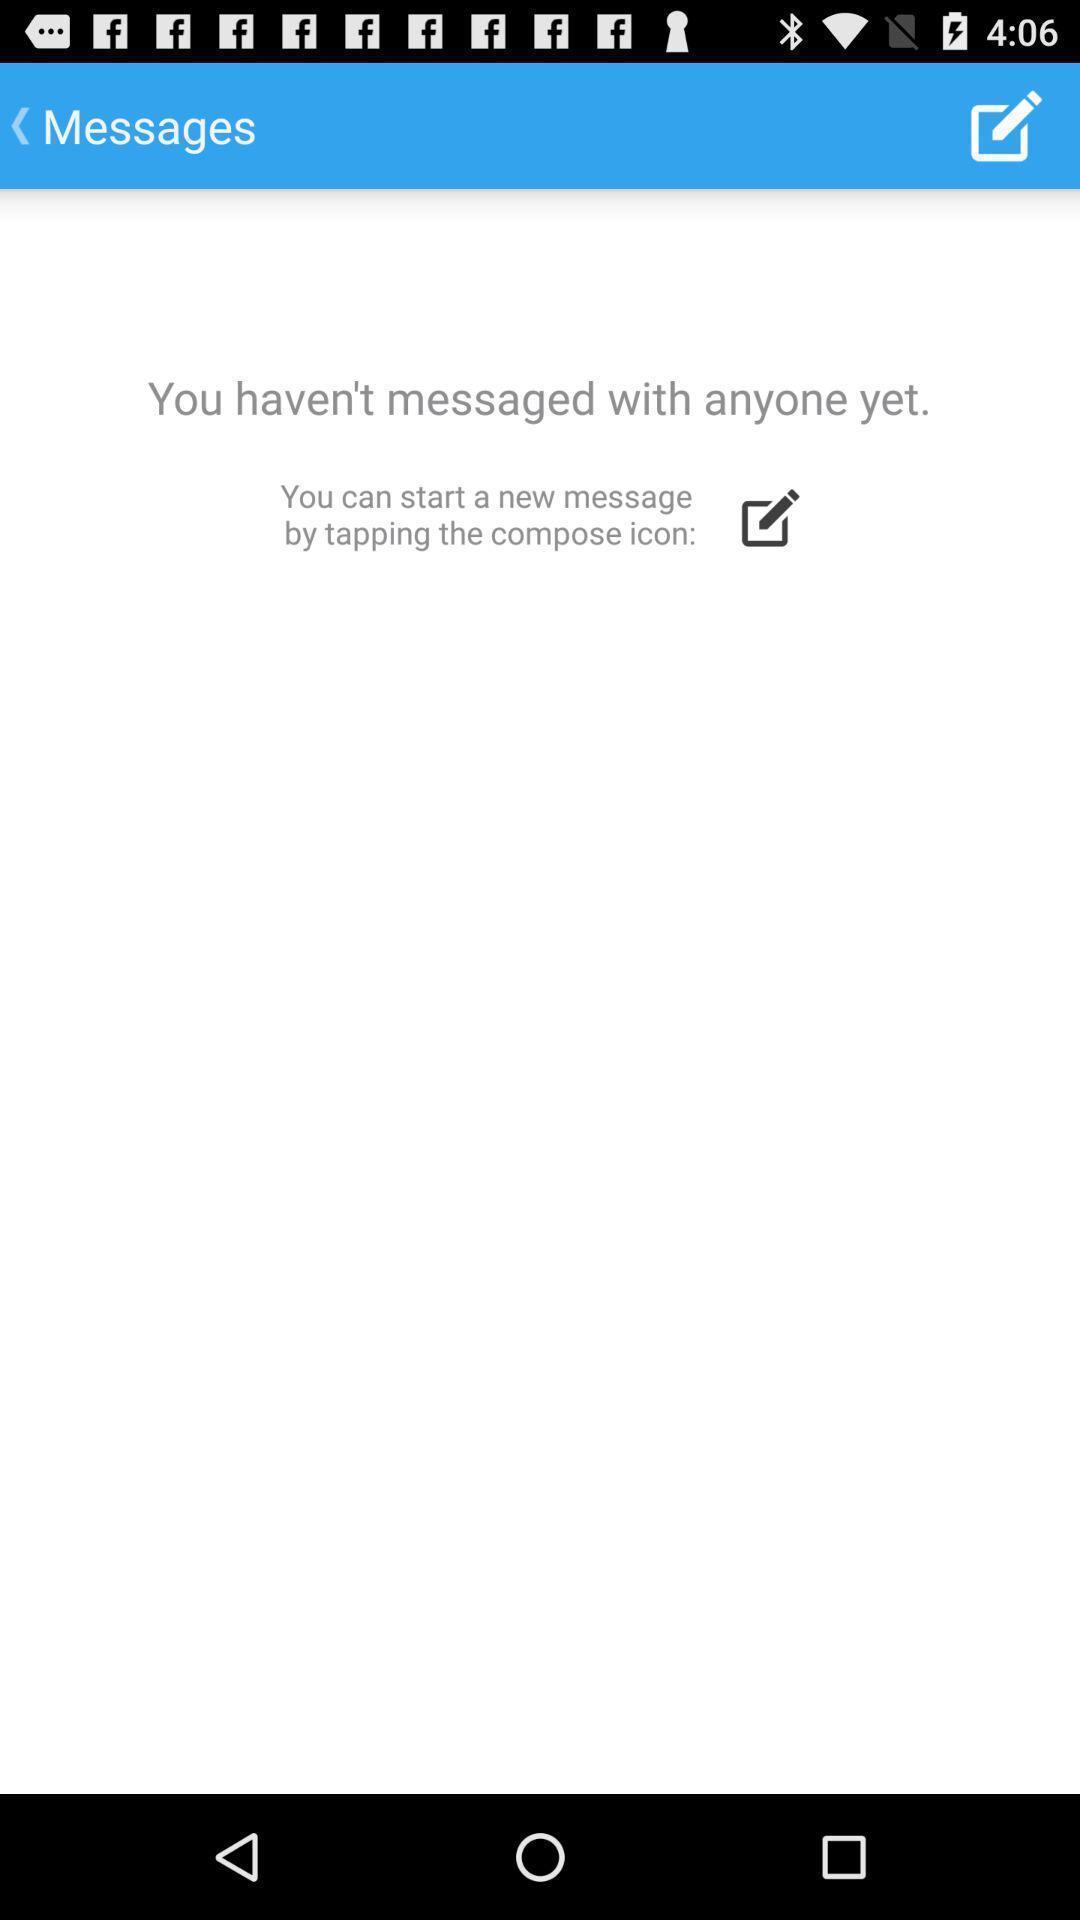What is the overall content of this screenshot? Page showing messages with no content. 